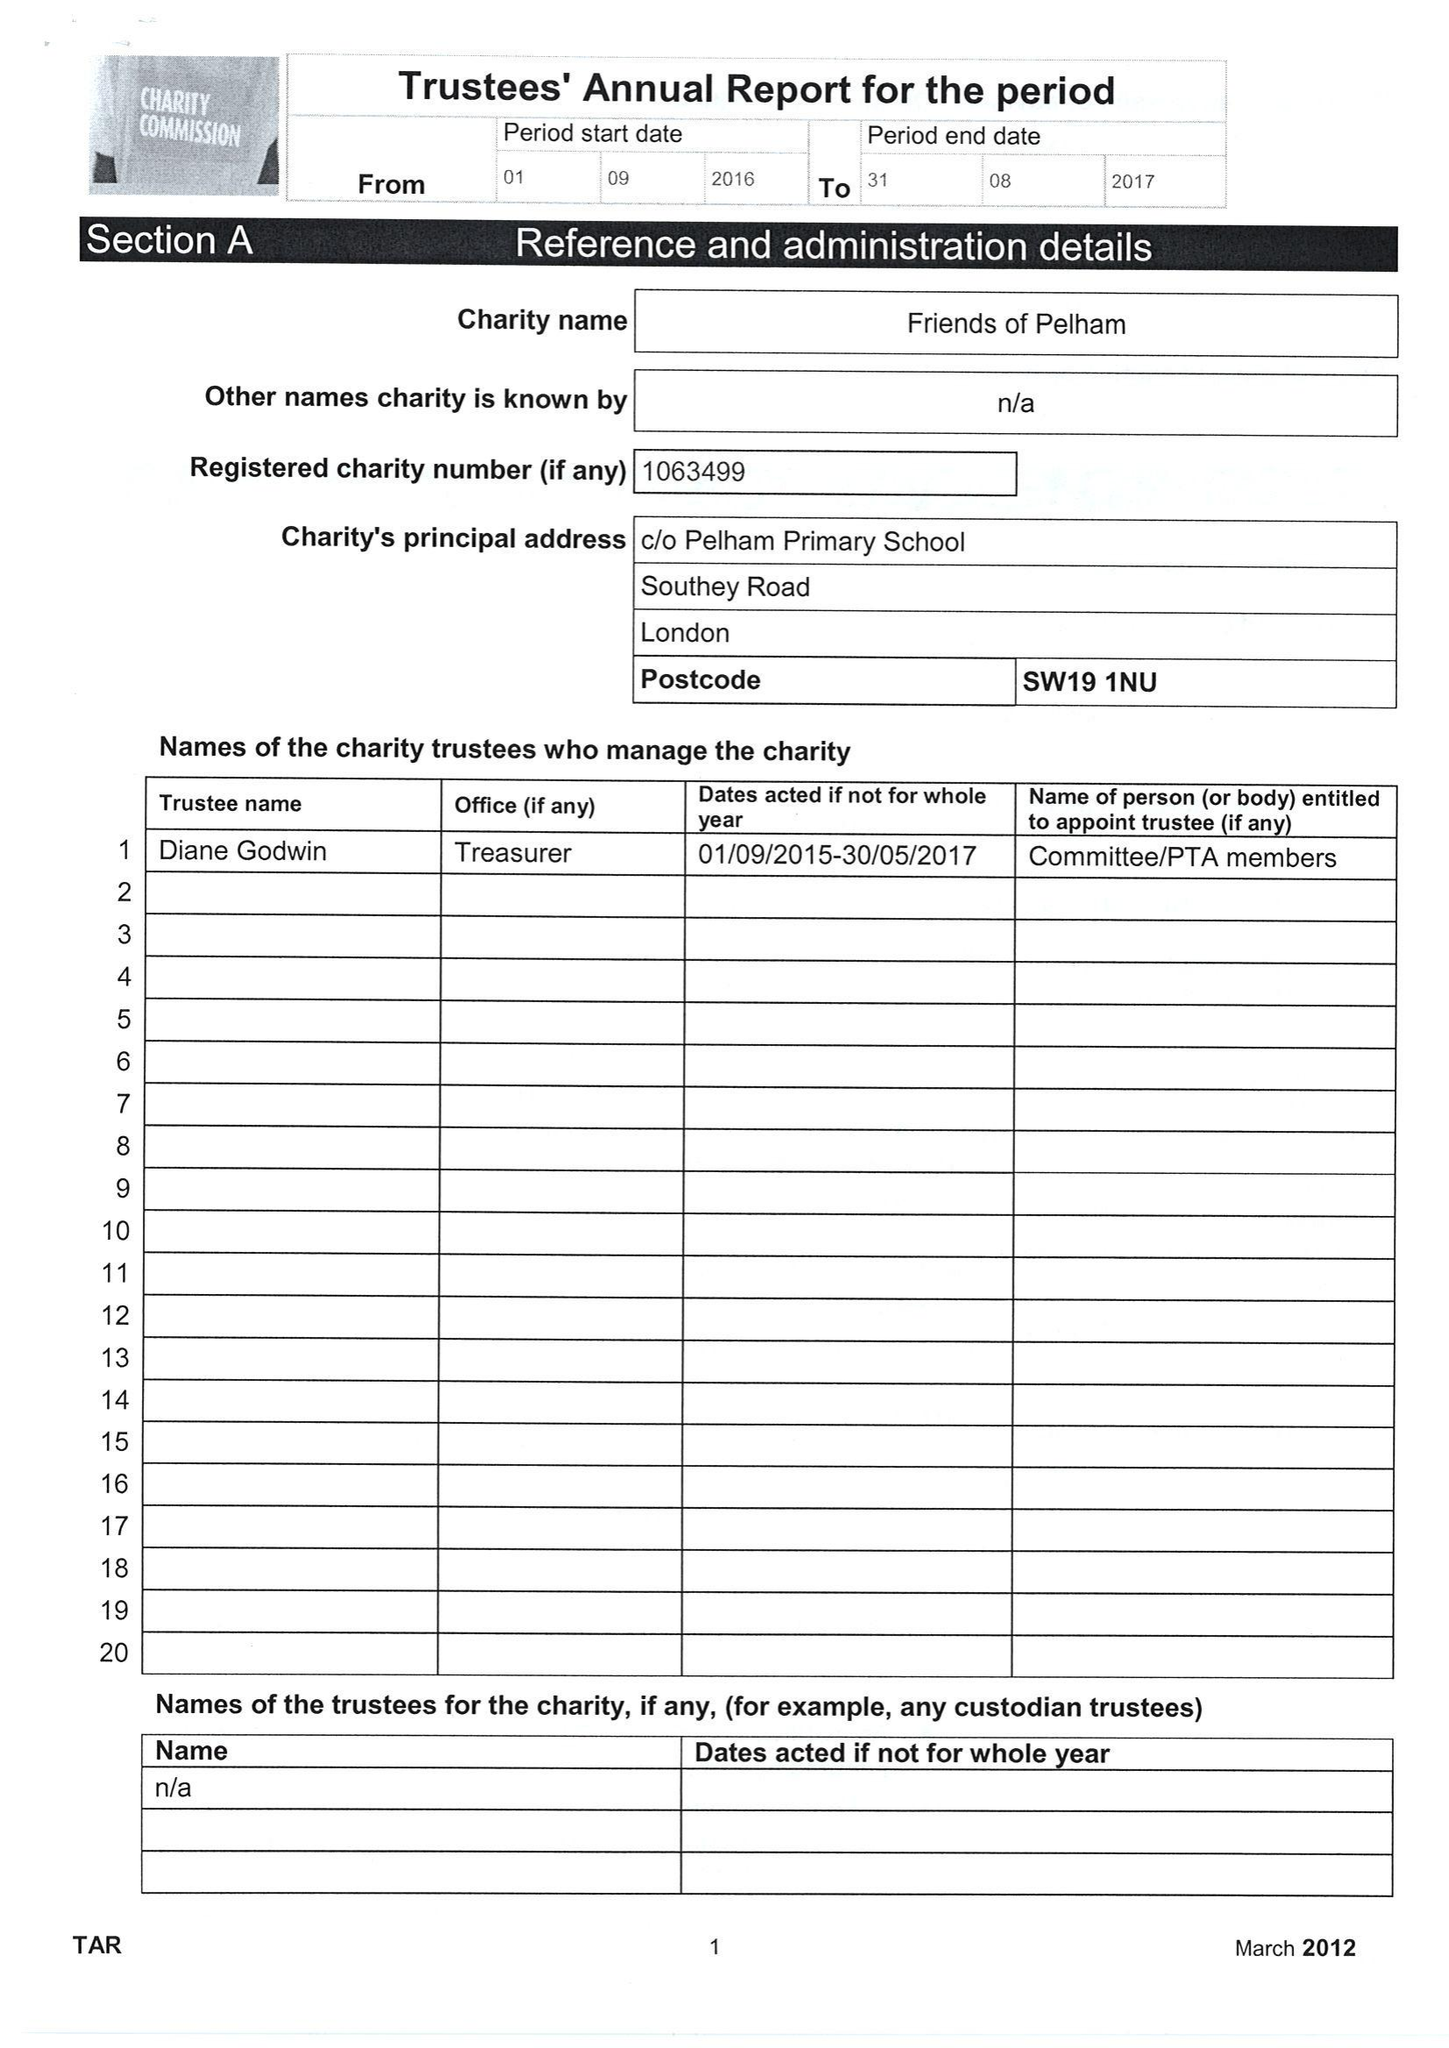What is the value for the address__post_town?
Answer the question using a single word or phrase. LONDON 